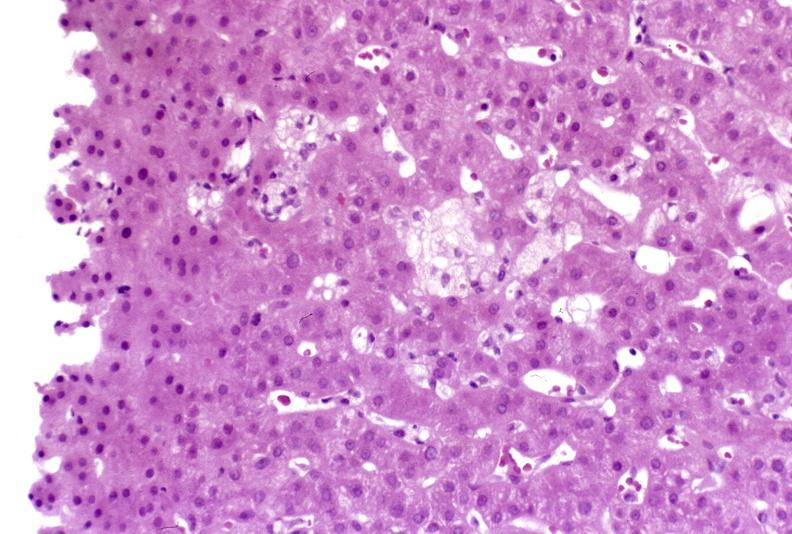s amputation stump infected present?
Answer the question using a single word or phrase. No 